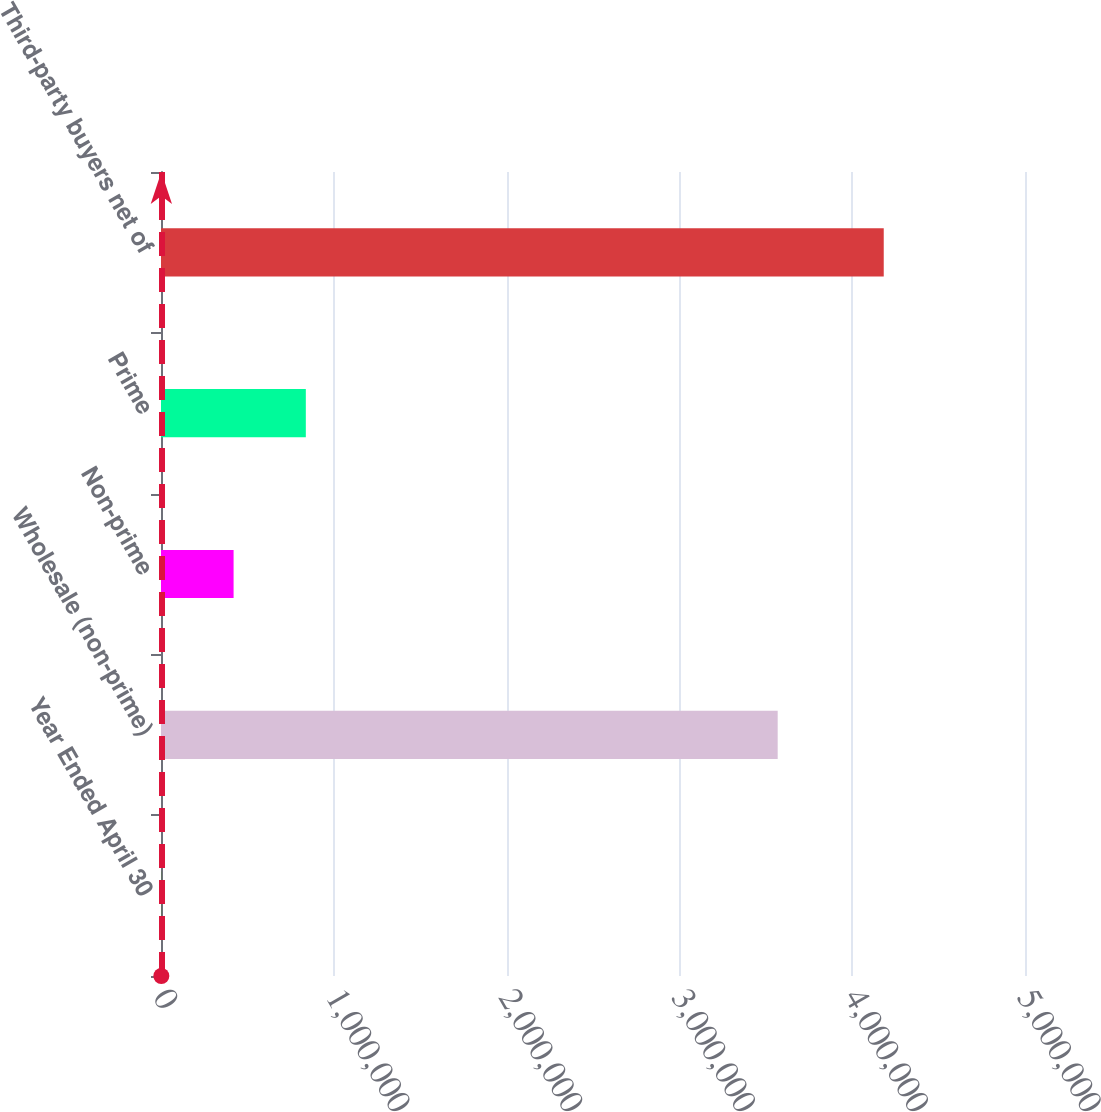Convert chart to OTSL. <chart><loc_0><loc_0><loc_500><loc_500><bar_chart><fcel>Year Ended April 30<fcel>Wholesale (non-prime)<fcel>Non-prime<fcel>Prime<fcel>Third-party buyers net of<nl><fcel>2008<fcel>3.56882e+06<fcel>420060<fcel>838112<fcel>4.18253e+06<nl></chart> 